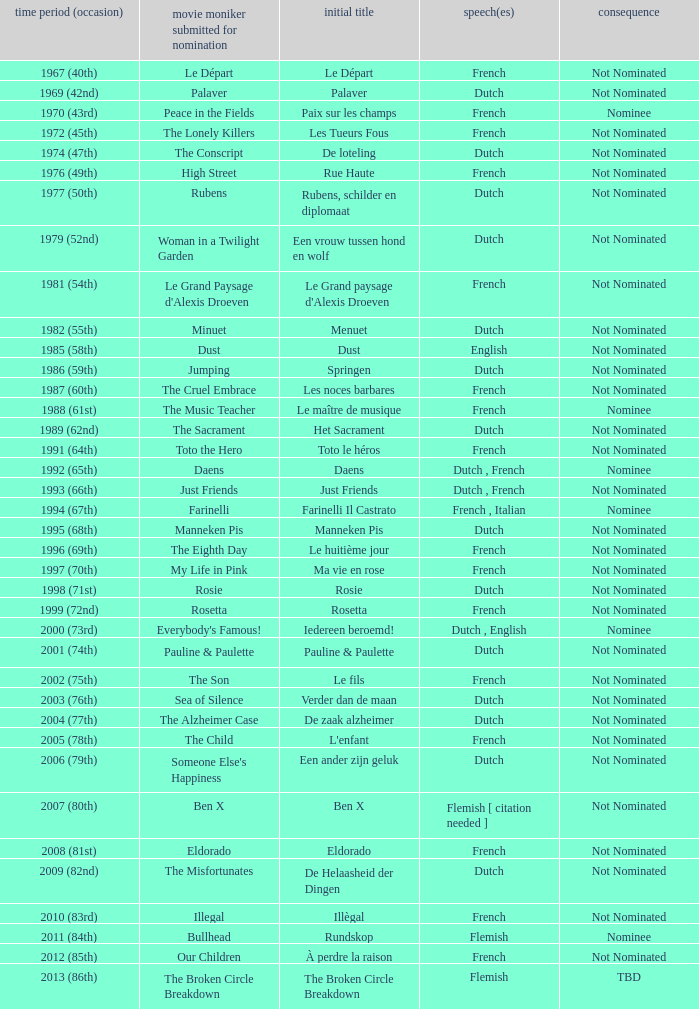What was the title used for Rosie, the film nominated for the dutch language? Rosie. 